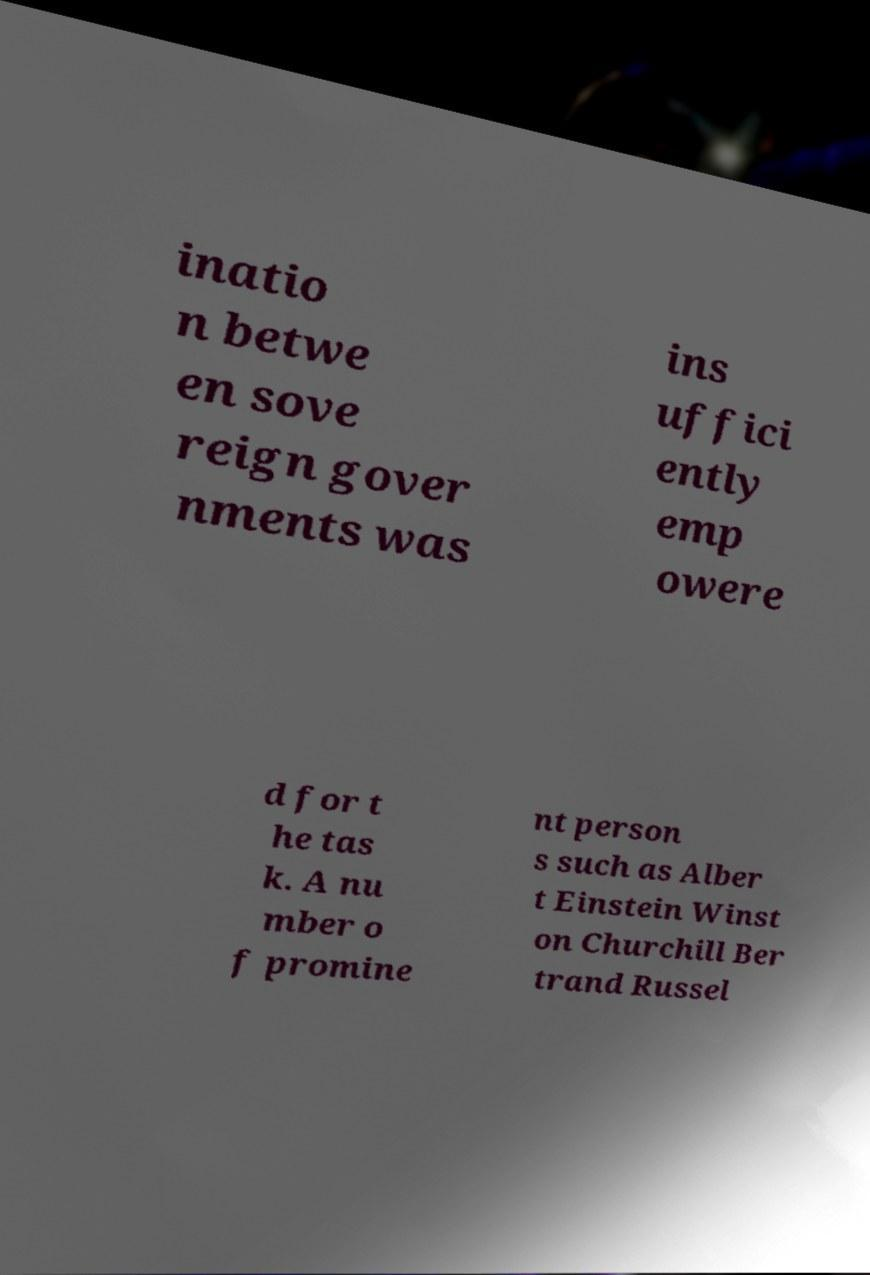Please read and relay the text visible in this image. What does it say? inatio n betwe en sove reign gover nments was ins uffici ently emp owere d for t he tas k. A nu mber o f promine nt person s such as Alber t Einstein Winst on Churchill Ber trand Russel 